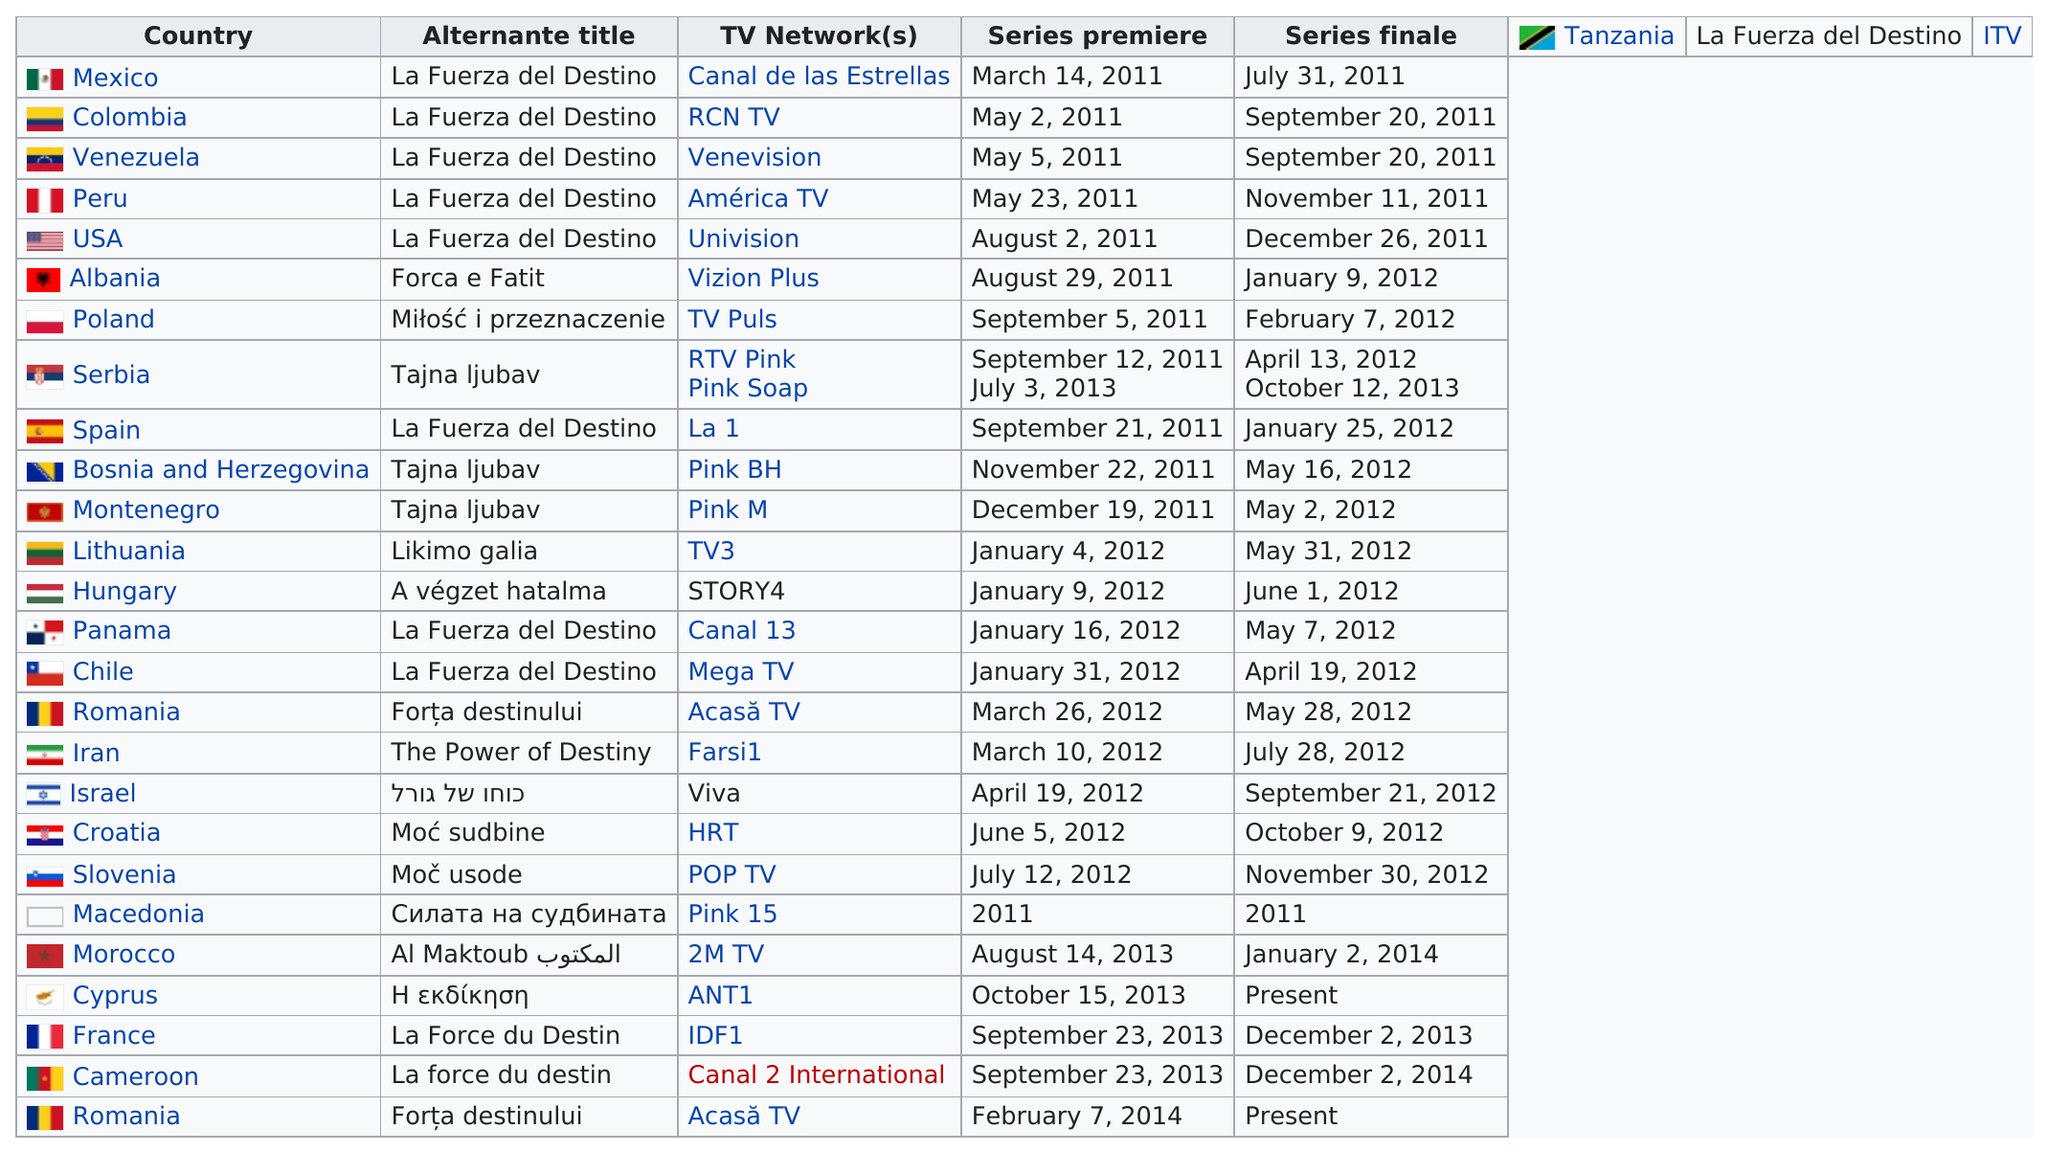Outline some significant characteristics in this image. The series finale aired in six countries before it aired in Spain. The alternate title "La Fuerza del Destino" is currently available in 8 countries. The broadcast lasted from September 21, 2011 to January 25, 2012 in Spain. On September 23, 2013, in France, the premier was held, and it was concurrently held in Cameroon. The first series premiere in Peru took place on May 23, 2011. 